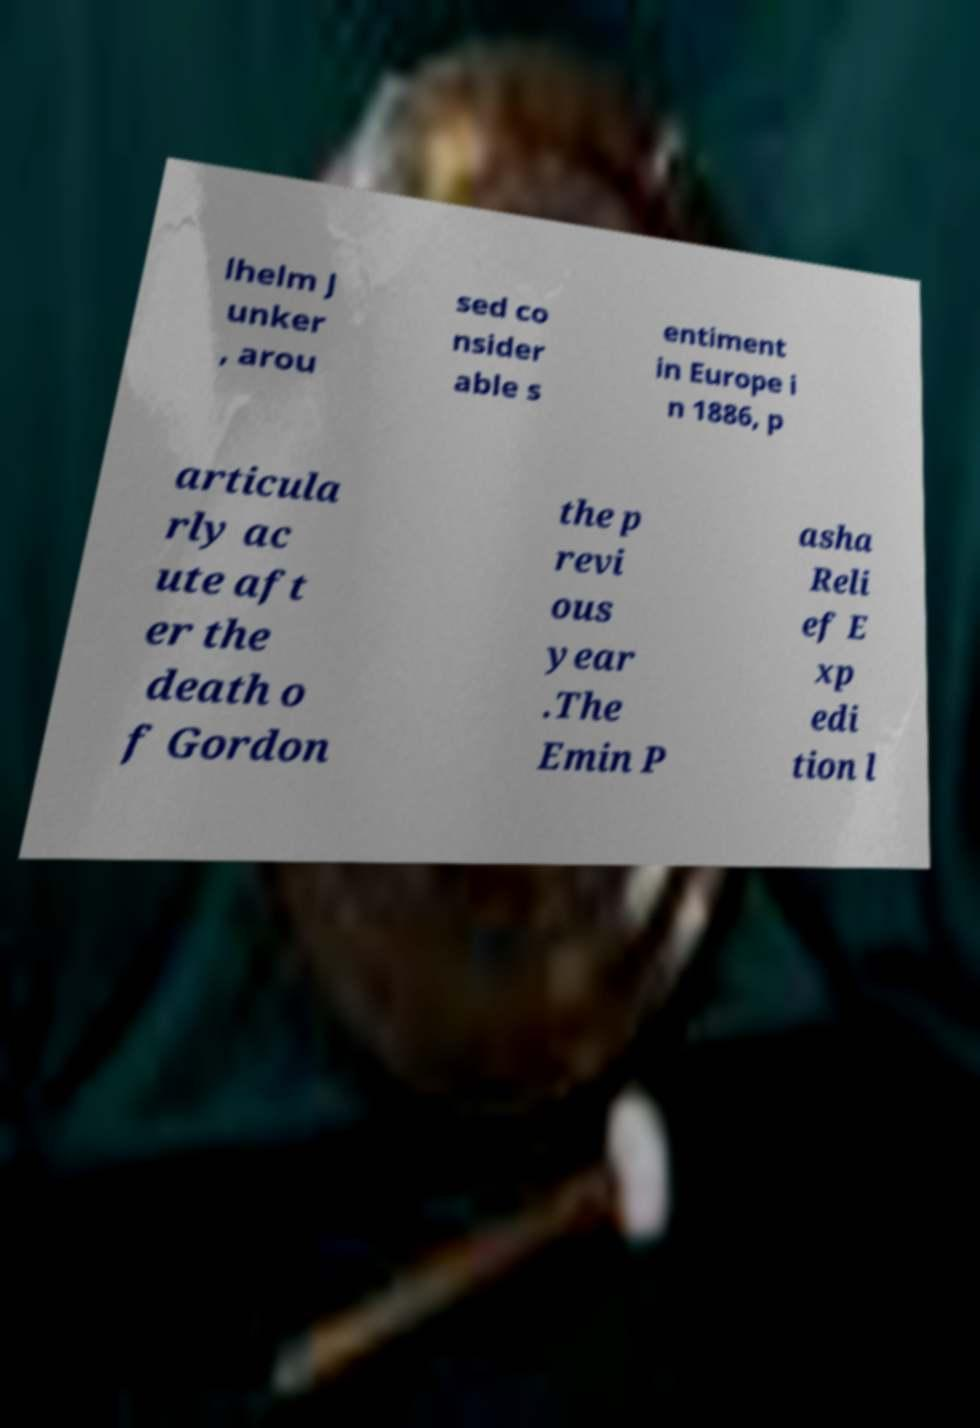I need the written content from this picture converted into text. Can you do that? lhelm J unker , arou sed co nsider able s entiment in Europe i n 1886, p articula rly ac ute aft er the death o f Gordon the p revi ous year .The Emin P asha Reli ef E xp edi tion l 